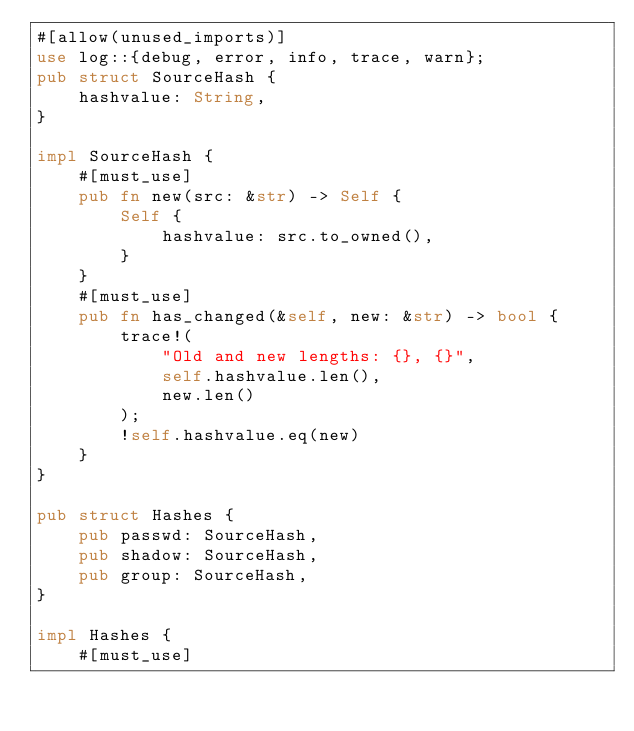<code> <loc_0><loc_0><loc_500><loc_500><_Rust_>#[allow(unused_imports)]
use log::{debug, error, info, trace, warn};
pub struct SourceHash {
    hashvalue: String,
}

impl SourceHash {
    #[must_use]
    pub fn new(src: &str) -> Self {
        Self {
            hashvalue: src.to_owned(),
        }
    }
    #[must_use]
    pub fn has_changed(&self, new: &str) -> bool {
        trace!(
            "Old and new lengths: {}, {}",
            self.hashvalue.len(),
            new.len()
        );
        !self.hashvalue.eq(new)
    }
}

pub struct Hashes {
    pub passwd: SourceHash,
    pub shadow: SourceHash,
    pub group: SourceHash,
}

impl Hashes {
    #[must_use]</code> 